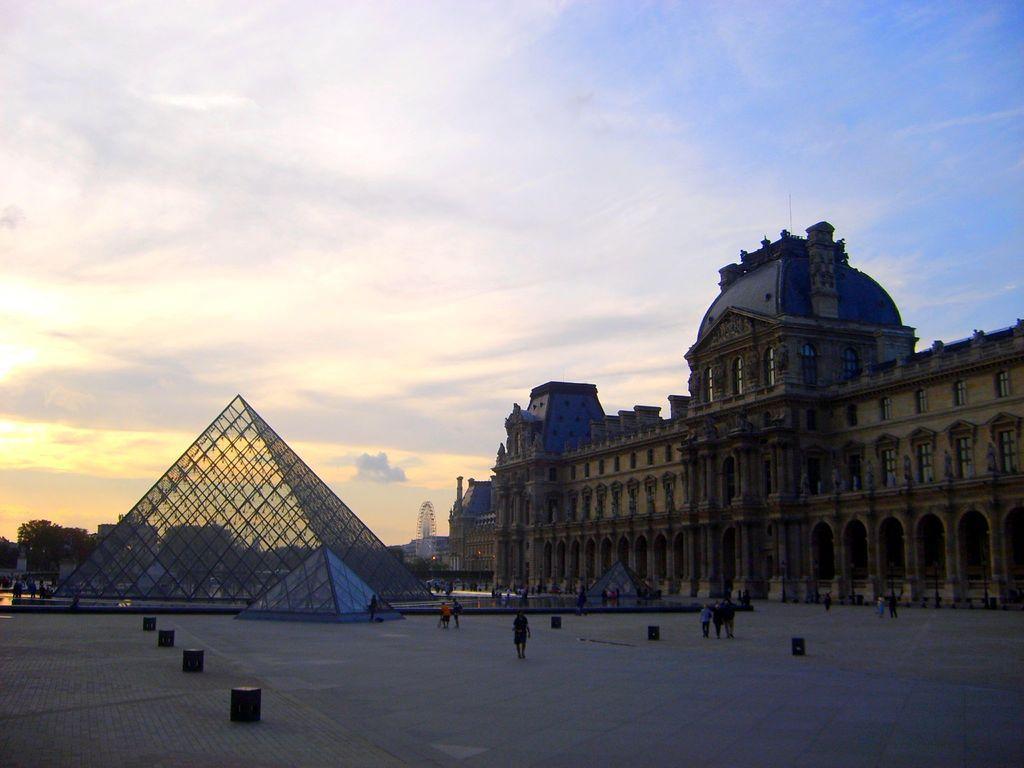Can you describe this image briefly? On the right side of the image we can see giant wheel and buildings. On the left side of the image we can see glass buildings. At the bottom there are persons on the road. In the background we can see trees, buildings, sky and clouds. 